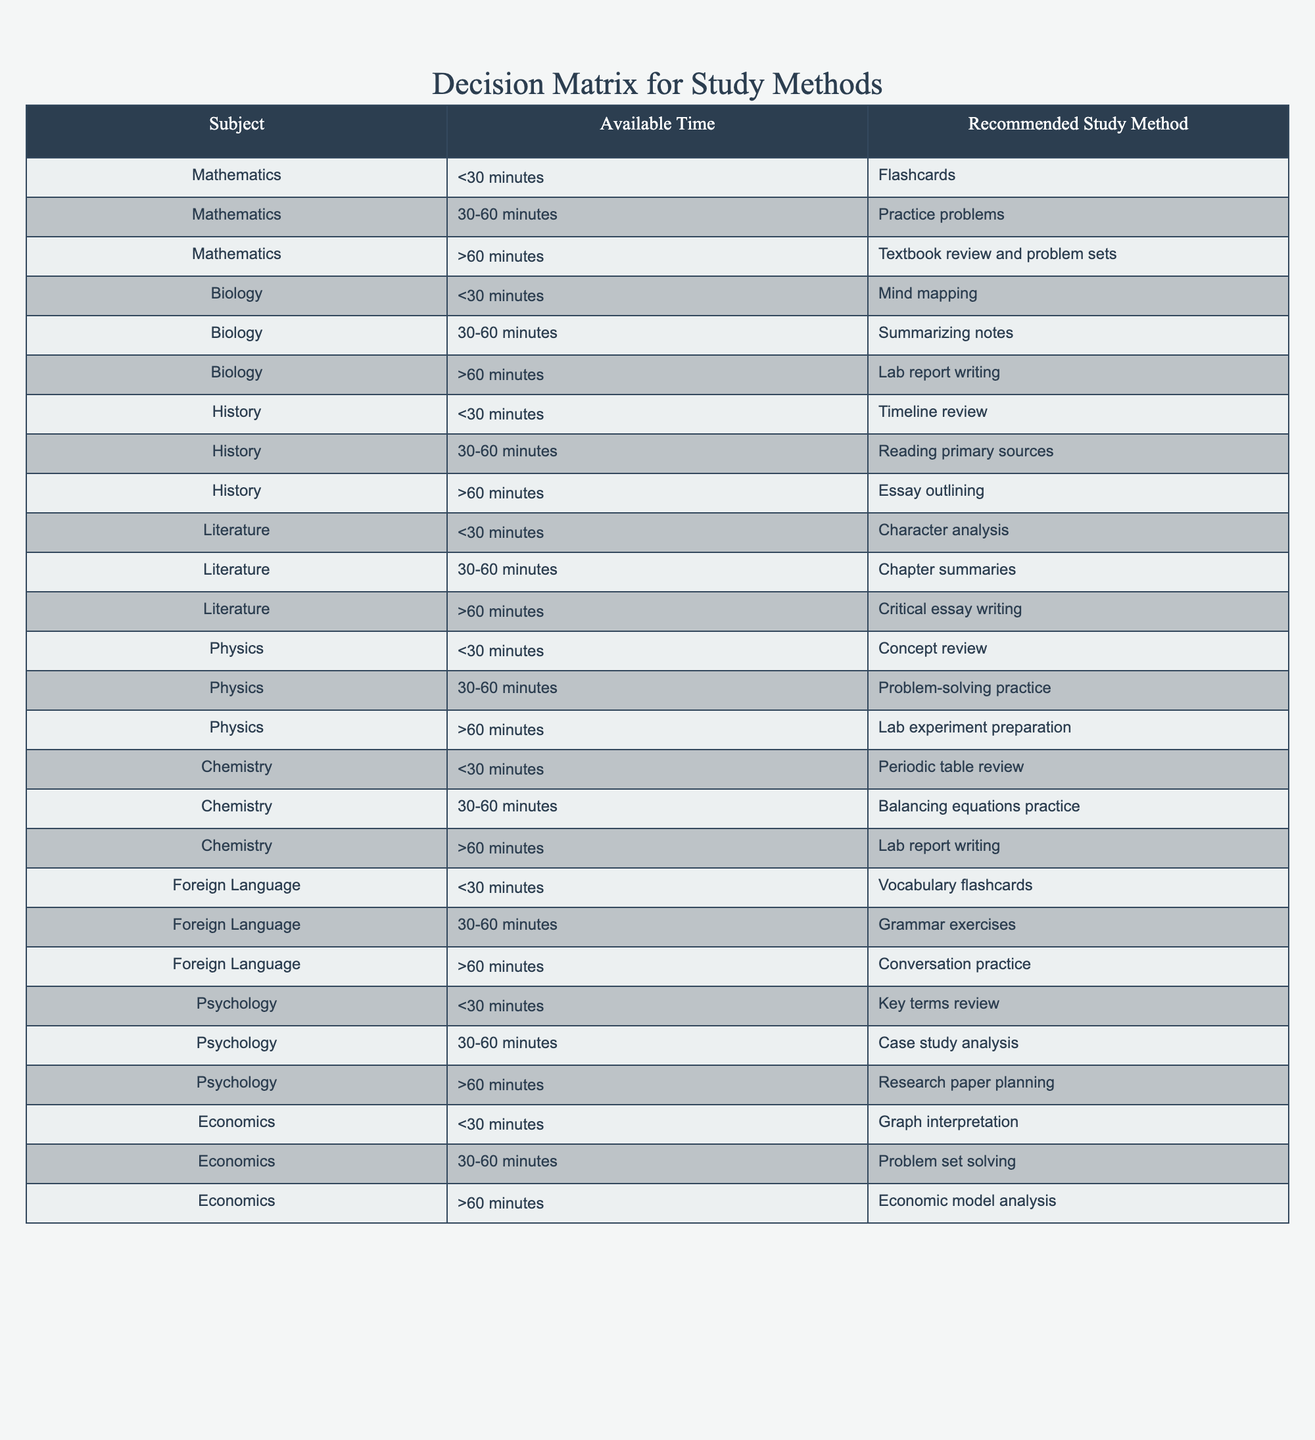What study method is recommended for Mathematics if the available time is less than 30 minutes? According to the table, for Mathematics with less than 30 minutes of available time, the recommended study method is flashcards.
Answer: Flashcards What is the recommended study method for Biology with more than 60 minutes available? The table indicates that for Biology when there is more than 60 minutes available, the recommended study method is lab report writing.
Answer: Lab report writing In which subject would you likely use vocabulary flashcards if you only have less than 30 minutes to study? The table shows that for Foreign Language, the recommended study method when there is less than 30 minutes available is vocabulary flashcards. Therefore, the subject is Foreign Language.
Answer: Foreign Language Does the decision table recommend reading primary sources for History if you have between 30 to 60 minutes available? Yes, the table lists reading primary sources as the recommended study method for History with 30-60 minutes of available time.
Answer: Yes If a student has 10 subjects to study and wants to use textbook review and problem sets for Mathematics, how much time must they allocate? Based on the table, textbook review and problem sets are only recommended for Mathematics when the available time is greater than 60 minutes. This means if a student wants to use this method, they need to allocate more than 60 minutes for Mathematics.
Answer: More than 60 minutes What is the total number of subjects that recommend practicing problems for 30 to 60 minutes? By examining the table, we can identify the subjects that suggest the recommended study method of practice problems for 30-60 minutes: Mathematics, Physics, Economics—all of which totals to three subjects.
Answer: 3 What study method is recommended for Psychology with less than 30 minutes available? For Psychology, the table specifies that the recommended study method when there is less than 30 minutes available is key terms review.
Answer: Key terms review If a student wants to dedicate exactly one hour to study Chemistry, what study method should they use? The table suggests that if a student has 30 to 60 minutes available for Chemistry, they should practice balancing equations. Therefore, for a full hour, this is the recommended method.
Answer: Balancing equations practice Is it true that for all subjects more than 60 minutes available, lab report writing is the recommended study method? No, this statement is false as lab report writing is only recommended for specific subjects such as Biology and Chemistry. Other subjects such as Literature and Physics suggest different methods for more than 60 minutes.
Answer: No 